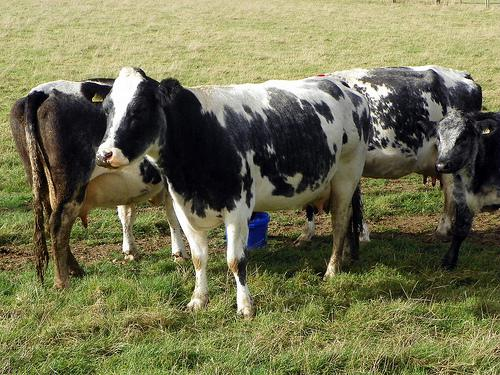Question: what animal is being shown?
Choices:
A. Horses.
B. Cows.
C. Goats.
D. Dogs.
Answer with the letter. Answer: B Question: where are the cows currently?
Choices:
A. In the barn.
B. In the water.
C. On the grass.
D. Field.
Answer with the letter. Answer: D Question: why are the cows eating?
Choices:
A. To grow fat.
B. They are hungry.
C. Nutrition.
D. It's time to eat.
Answer with the letter. Answer: C Question: how do the cows talk?
Choices:
A. Moving around.
B. Mooing.
C. Looking.
D. Telepathically.
Answer with the letter. Answer: B Question: what color is the bucket?
Choices:
A. Green.
B. Red.
C. Blue.
D. White.
Answer with the letter. Answer: C 